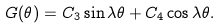Convert formula to latex. <formula><loc_0><loc_0><loc_500><loc_500>G ( \theta ) = C _ { 3 } \sin \lambda \theta + C _ { 4 } \cos \lambda \theta .</formula> 